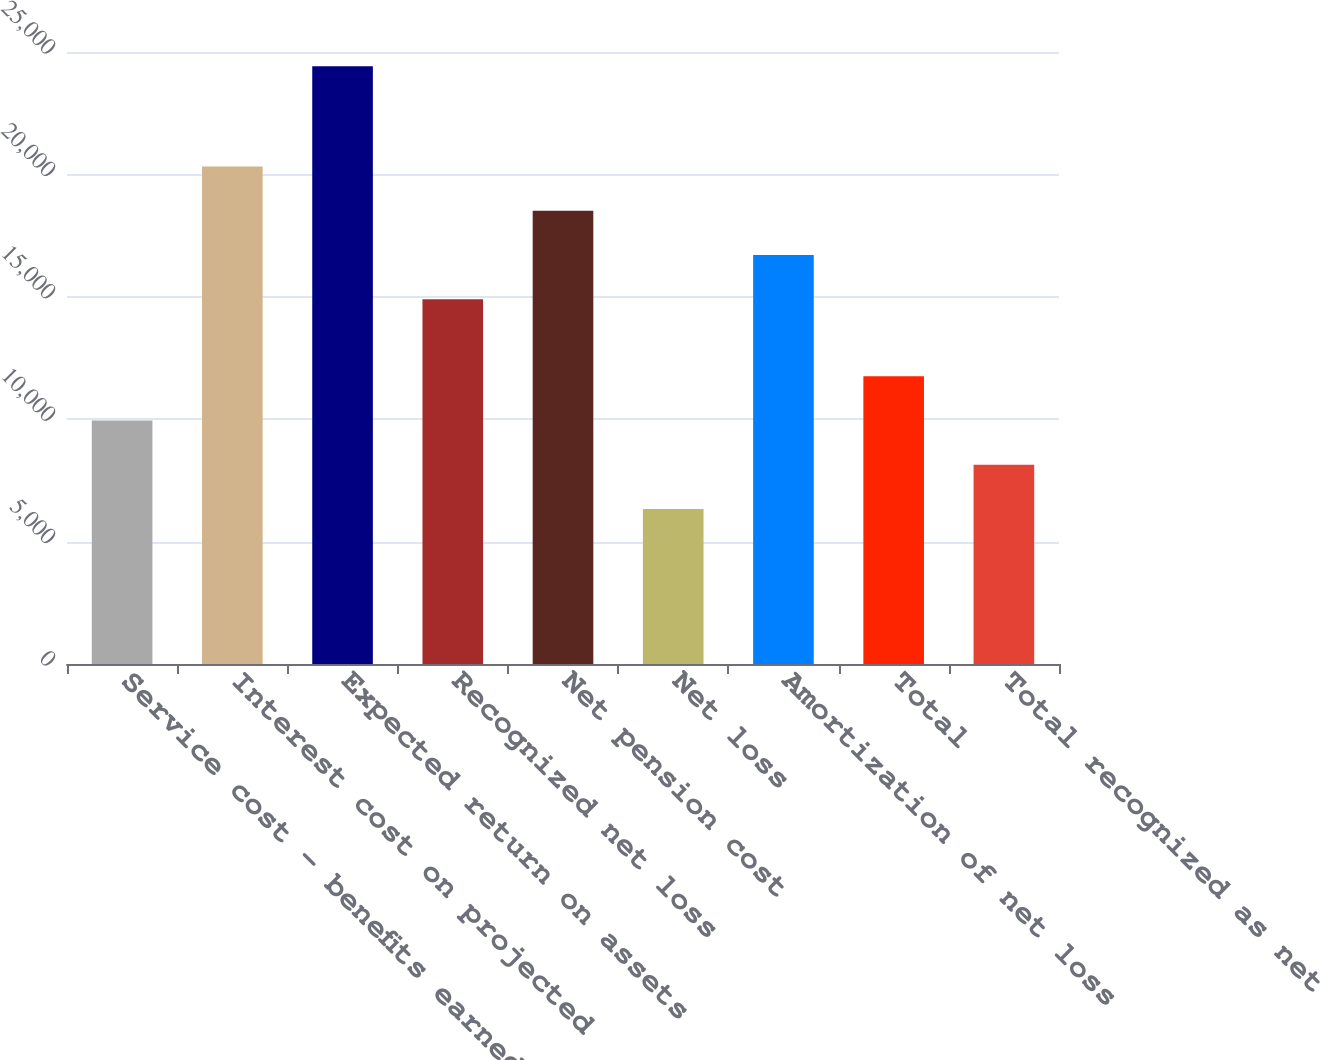<chart> <loc_0><loc_0><loc_500><loc_500><bar_chart><fcel>Service cost - benefits earned<fcel>Interest cost on projected<fcel>Expected return on assets<fcel>Recognized net loss<fcel>Net pension cost<fcel>Net loss<fcel>Amortization of net loss<fcel>Total<fcel>Total recognized as net<nl><fcel>9947.2<fcel>20323.3<fcel>24420<fcel>14896<fcel>18514.2<fcel>6329<fcel>16705.1<fcel>11756.3<fcel>8138.1<nl></chart> 